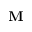Convert formula to latex. <formula><loc_0><loc_0><loc_500><loc_500>M</formula> 